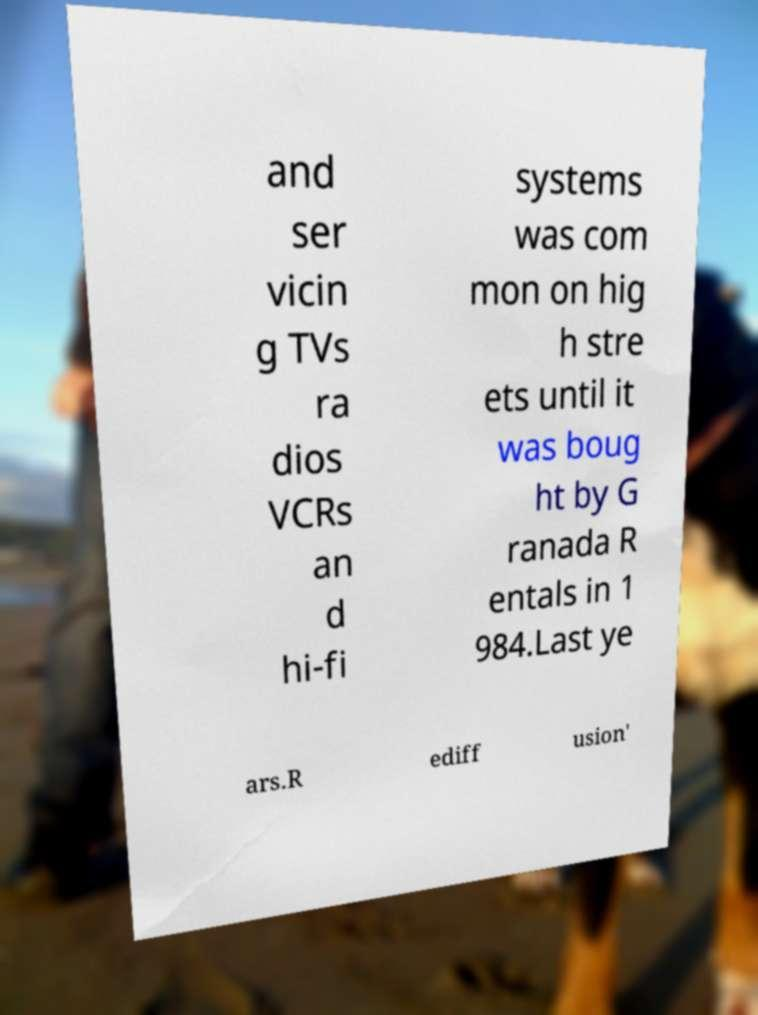Please read and relay the text visible in this image. What does it say? and ser vicin g TVs ra dios VCRs an d hi-fi systems was com mon on hig h stre ets until it was boug ht by G ranada R entals in 1 984.Last ye ars.R ediff usion' 